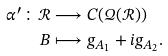Convert formula to latex. <formula><loc_0><loc_0><loc_500><loc_500>\alpha ^ { \prime } \colon \mathcal { R } & \longrightarrow C ( \mathcal { Q ( R ) } \mathbb { ) } \\ B & \longmapsto g _ { A _ { 1 } } + i g _ { A _ { 2 } } .</formula> 